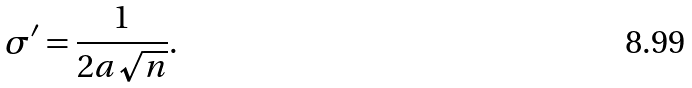<formula> <loc_0><loc_0><loc_500><loc_500>\sigma ^ { \prime } = \frac { 1 } { 2 a \sqrt { n } } .</formula> 